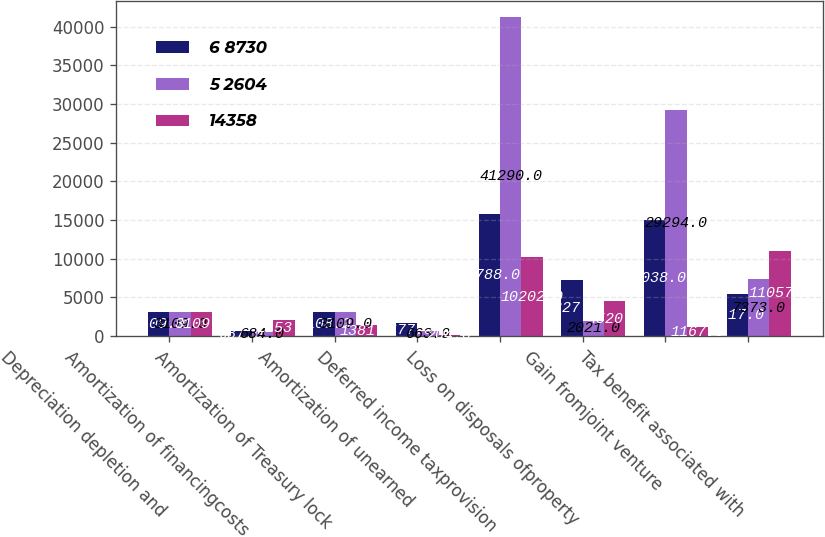<chart> <loc_0><loc_0><loc_500><loc_500><stacked_bar_chart><ecel><fcel>Depreciation depletion and<fcel>Amortization of financingcosts<fcel>Amortization of Treasury lock<fcel>Amortization of unearned<fcel>Deferred income taxprovision<fcel>Loss on disposals ofproperty<fcel>Gain fromjoint venture<fcel>Tax benefit associated with<nl><fcel>6 8730<fcel>3109<fcel>687<fcel>3108<fcel>1677<fcel>15788<fcel>7227<fcel>15038<fcel>5417<nl><fcel>5 2604<fcel>3109<fcel>684<fcel>3109<fcel>663<fcel>41290<fcel>2021<fcel>29294<fcel>7373<nl><fcel>14358<fcel>3109<fcel>2153<fcel>1381<fcel>204<fcel>10202<fcel>4520<fcel>1167<fcel>11057<nl></chart> 